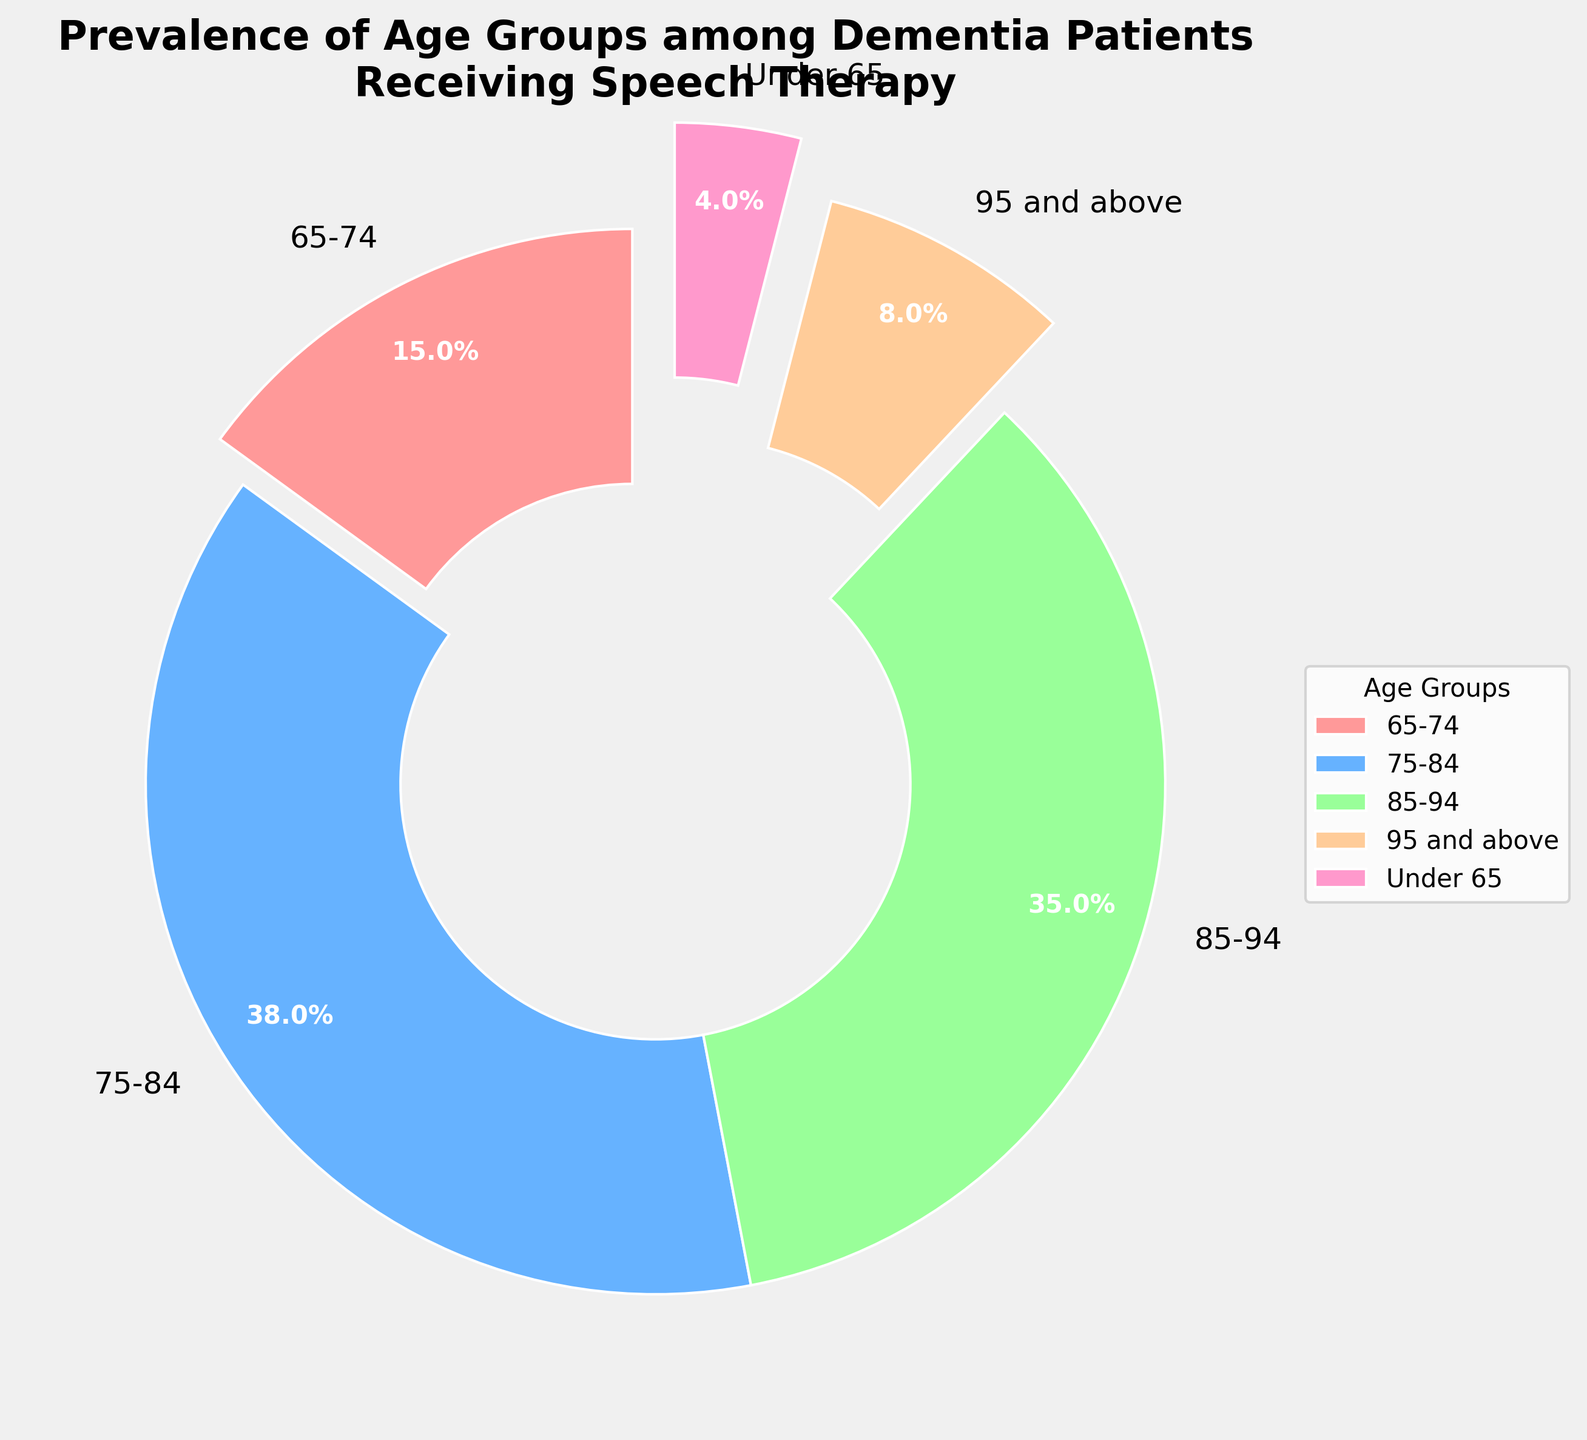Which age group has the highest prevalence among dementia patients receiving speech therapy? The pie chart shows that the age group 75-84 has the largest percentage slice, which is indicated as 38%.
Answer: 75-84 What is the combined percentage of dementia patients in the age groups under 65 and 65-74? The pie chart shows the percentages for the age groups Under 65 (4%) and 65-74 (15%). Adding these together gives 4% + 15% = 19%.
Answer: 19% Is the prevalence of patients aged 85-94 higher or lower than those aged 65-74? The pie chart shows that the percentage for the age group 85-94 is 35%, while the age group 65-74 has 15%. Since 35% is greater than 15%, the prevalence for 85-94 is higher.
Answer: Higher Which age group makes up the smallest portion of the dementia patients receiving speech therapy? The pie chart indicates that the age group Under 65 has the smallest segment with 4%.
Answer: Under 65 How does the prevalence of patients aged 95 and above compare to those aged 85-94 in terms of percentage points difference? The pie chart shows that the percentage for the age group 95 and above is 8%, while that for 85-94 is 35%. The difference in percentage points is 35% - 8% = 27%.
Answer: 27% Which age group is represented by a red slice in the pie chart? By visually inspecting the pie chart, the red slice corresponds to the age group 65-74.
Answer: 65-74 What is the total percentage covered by patients aged 75 and above? The age groups 75-84, 85-94, and 95 and above are all above 75 years. Adding their percentages gives 38% + 35% + 8% = 81%.
Answer: 81% What is the difference between the percentage of patients in the 75-84 age group and the 65-74 age group? The pie chart indicates that the 75-84 age group is 38% and the 65-74 age group is 15%. The difference is 38% - 15% = 23%.
Answer: 23% What percentage of the total population falls into the age group of 85-94 and above combined? The percentages for the age groups 85-94 and 95 and above are 35% and 8% respectively. Adding these together gives 35% + 8% = 43%.
Answer: 43% 